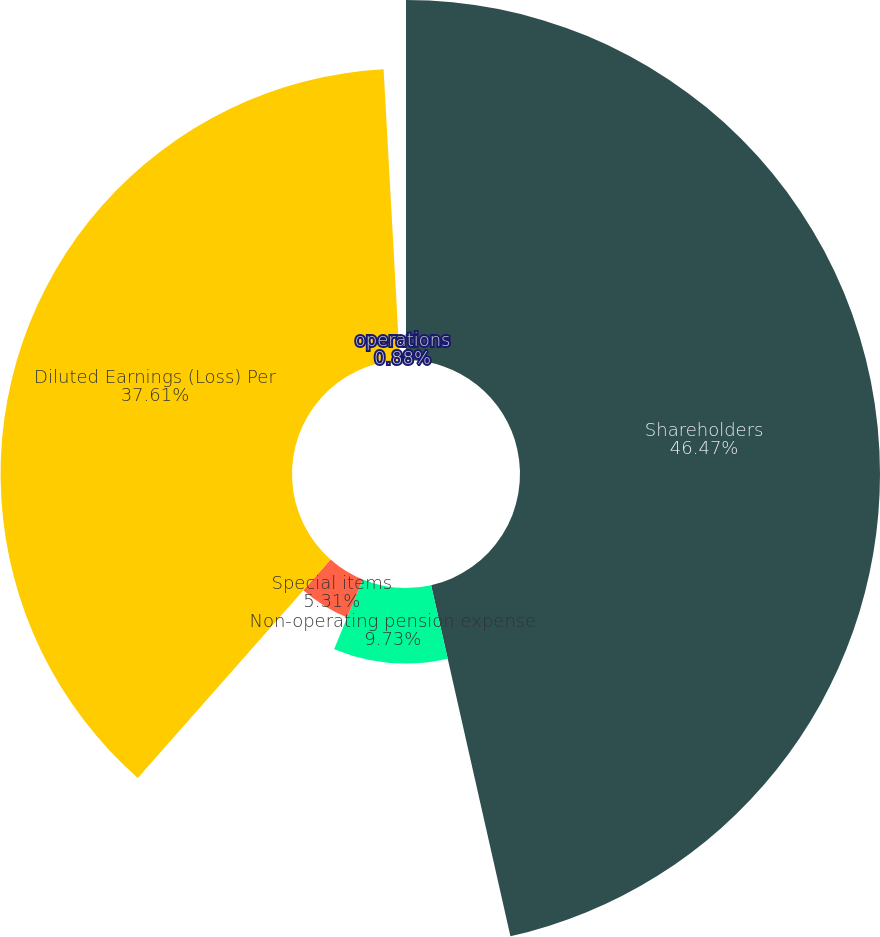<chart> <loc_0><loc_0><loc_500><loc_500><pie_chart><fcel>Shareholders<fcel>Non-operating pension expense<fcel>Special items<fcel>Diluted Earnings (Loss) Per<fcel>operations<nl><fcel>46.46%<fcel>9.73%<fcel>5.31%<fcel>37.61%<fcel>0.88%<nl></chart> 